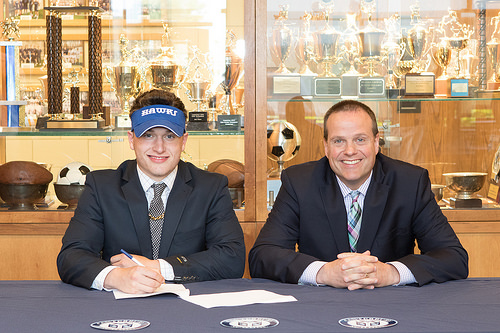<image>
Can you confirm if the blue hat is behind the trophy? No. The blue hat is not behind the trophy. From this viewpoint, the blue hat appears to be positioned elsewhere in the scene. 